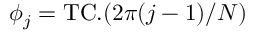Convert formula to latex. <formula><loc_0><loc_0><loc_500><loc_500>\phi _ { j } = T C . ( 2 \pi ( j - 1 ) / N )</formula> 